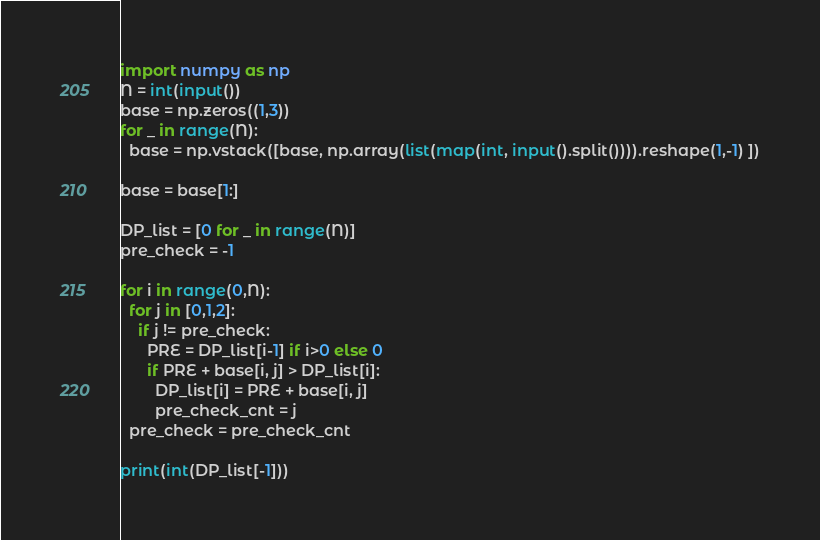Convert code to text. <code><loc_0><loc_0><loc_500><loc_500><_Python_>import numpy as np
N = int(input())
base = np.zeros((1,3))
for _ in range(N):
  base = np.vstack([base, np.array(list(map(int, input().split()))).reshape(1,-1) ])

base = base[1:]

DP_list = [0 for _ in range(N)]
pre_check = -1

for i in range(0,N):
  for j in [0,1,2]:
    if j != pre_check:
      PRE = DP_list[i-1] if i>0 else 0
      if PRE + base[i, j] > DP_list[i]:
        DP_list[i] = PRE + base[i, j]
        pre_check_cnt = j
  pre_check = pre_check_cnt

print(int(DP_list[-1]))</code> 